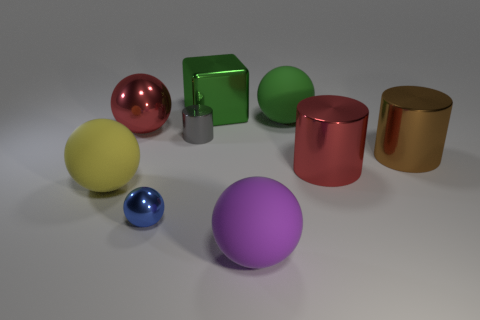Subtract all yellow spheres. How many spheres are left? 4 Subtract all red balls. How many balls are left? 4 Subtract all green spheres. Subtract all brown cubes. How many spheres are left? 4 Subtract all cylinders. How many objects are left? 6 Add 2 big brown metal cylinders. How many big brown metal cylinders exist? 3 Subtract 1 green balls. How many objects are left? 8 Subtract all big spheres. Subtract all cylinders. How many objects are left? 2 Add 7 large green things. How many large green things are left? 9 